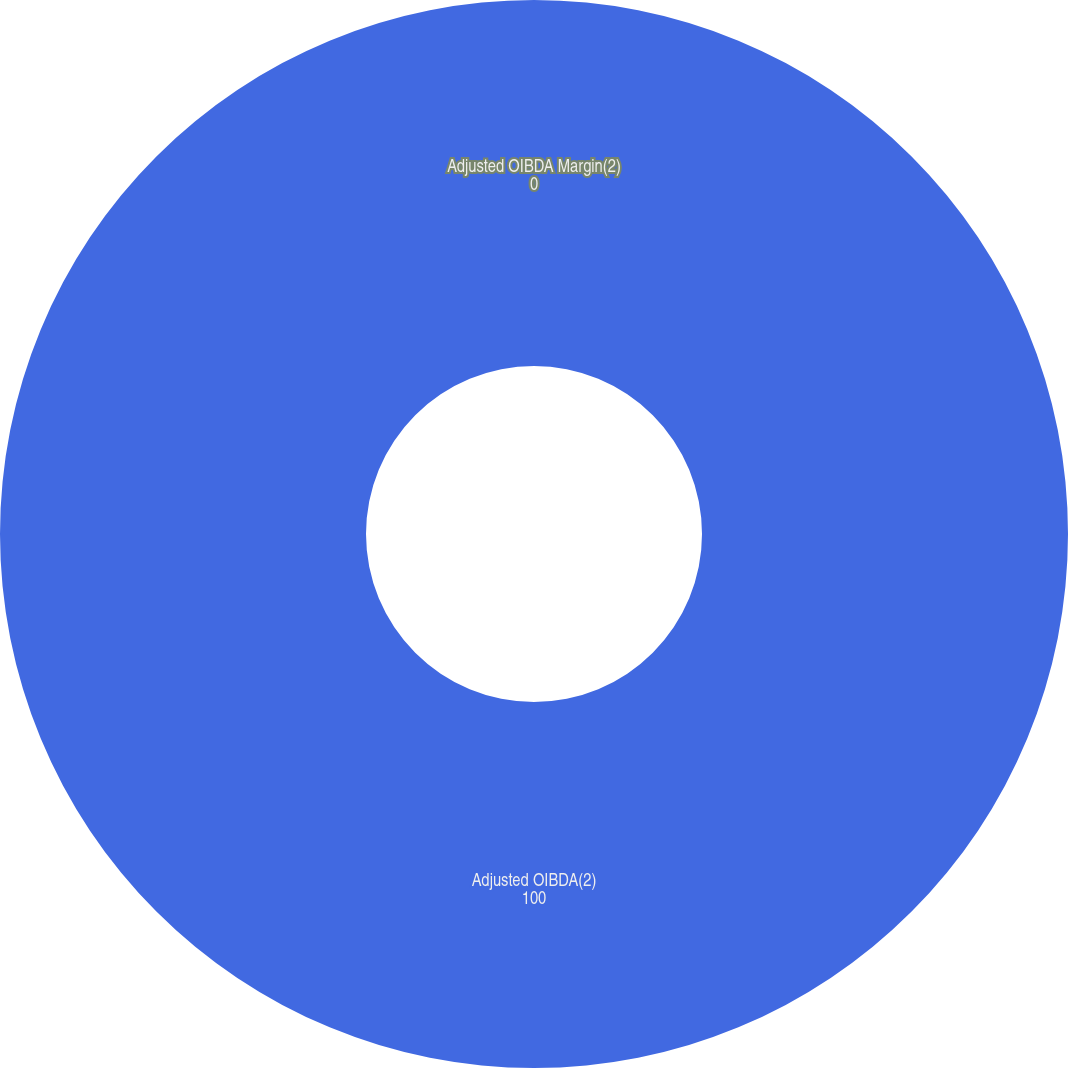Convert chart. <chart><loc_0><loc_0><loc_500><loc_500><pie_chart><fcel>Adjusted OIBDA(2)<fcel>Adjusted OIBDA Margin(2)<nl><fcel>100.0%<fcel>0.0%<nl></chart> 